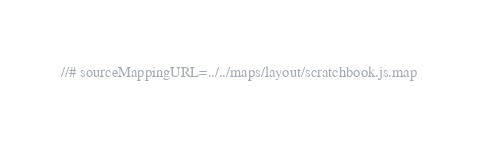<code> <loc_0><loc_0><loc_500><loc_500><_JavaScript_>//# sourceMappingURL=../../maps/layout/scratchbook.js.map
</code> 